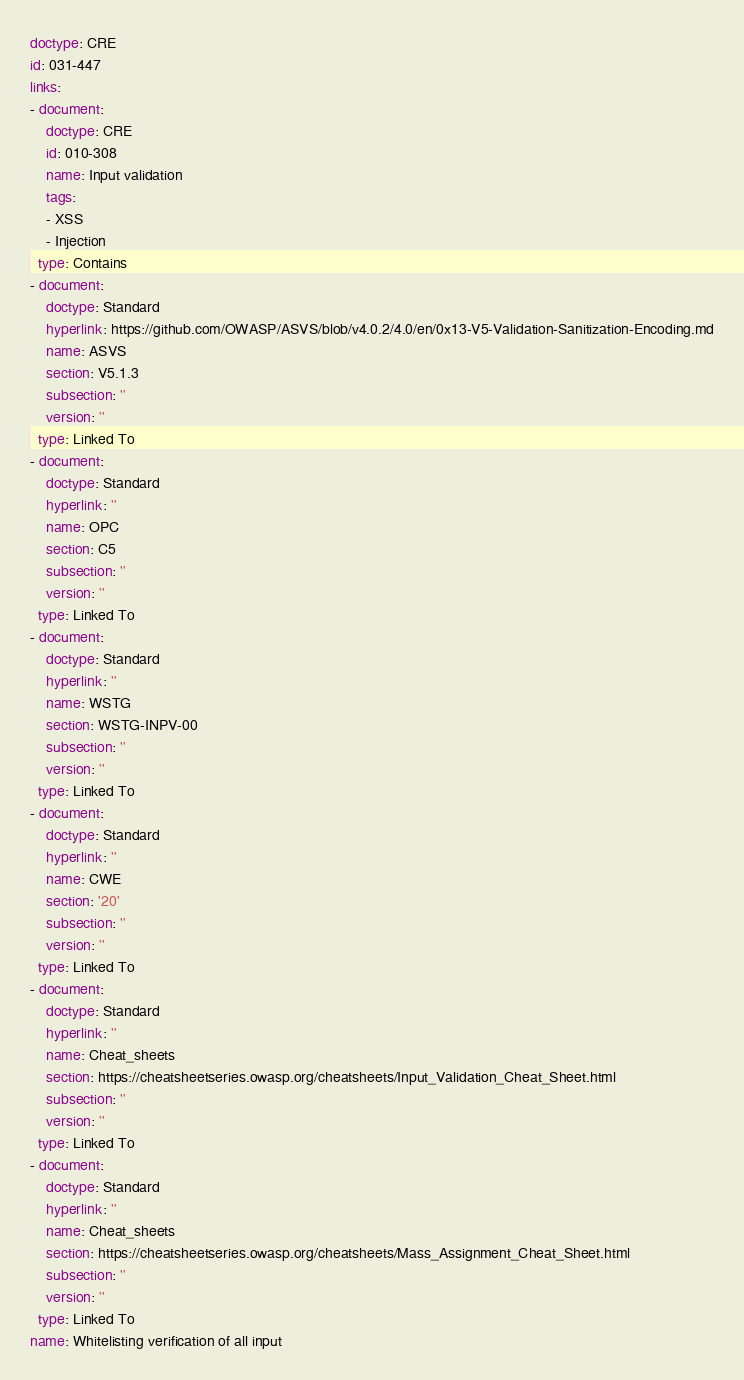Convert code to text. <code><loc_0><loc_0><loc_500><loc_500><_YAML_>doctype: CRE
id: 031-447
links:
- document:
    doctype: CRE
    id: 010-308
    name: Input validation
    tags:
    - XSS
    - Injection
  type: Contains
- document:
    doctype: Standard
    hyperlink: https://github.com/OWASP/ASVS/blob/v4.0.2/4.0/en/0x13-V5-Validation-Sanitization-Encoding.md
    name: ASVS
    section: V5.1.3
    subsection: ''
    version: ''
  type: Linked To
- document:
    doctype: Standard
    hyperlink: ''
    name: OPC
    section: C5
    subsection: ''
    version: ''
  type: Linked To
- document:
    doctype: Standard
    hyperlink: ''
    name: WSTG
    section: WSTG-INPV-00
    subsection: ''
    version: ''
  type: Linked To
- document:
    doctype: Standard
    hyperlink: ''
    name: CWE
    section: '20'
    subsection: ''
    version: ''
  type: Linked To
- document:
    doctype: Standard
    hyperlink: ''
    name: Cheat_sheets
    section: https://cheatsheetseries.owasp.org/cheatsheets/Input_Validation_Cheat_Sheet.html
    subsection: ''
    version: ''
  type: Linked To
- document:
    doctype: Standard
    hyperlink: ''
    name: Cheat_sheets
    section: https://cheatsheetseries.owasp.org/cheatsheets/Mass_Assignment_Cheat_Sheet.html
    subsection: ''
    version: ''
  type: Linked To
name: Whitelisting verification of all input
</code> 